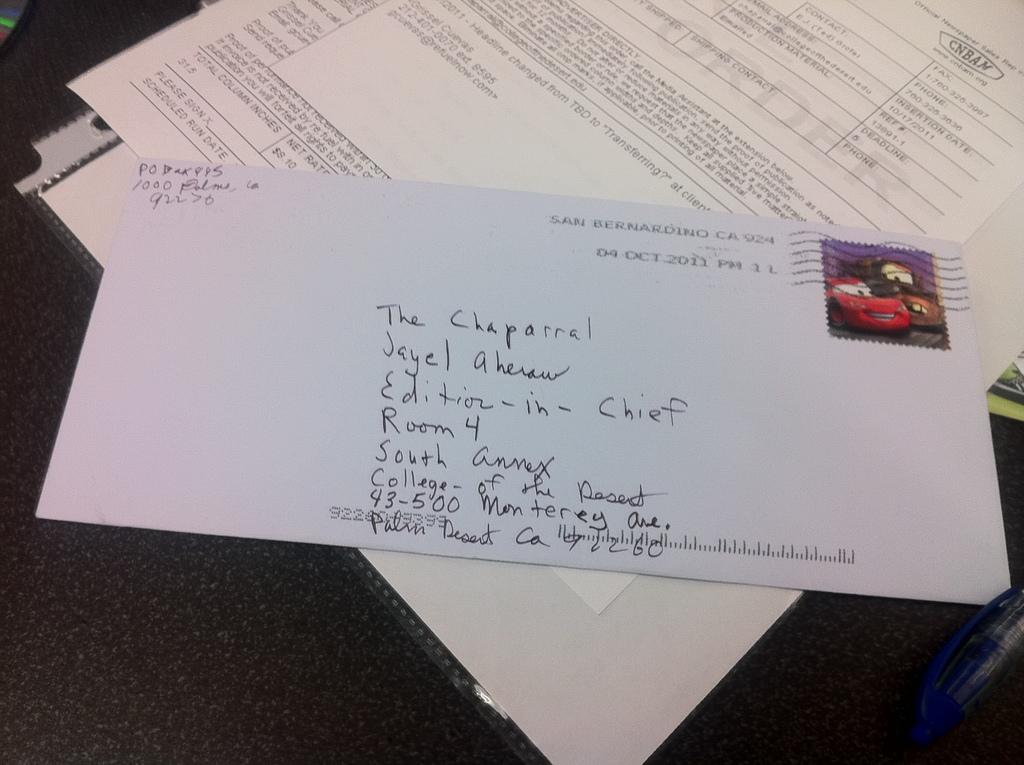<image>
Give a short and clear explanation of the subsequent image. An envelope addressed to California on top of some mail on a desk. 